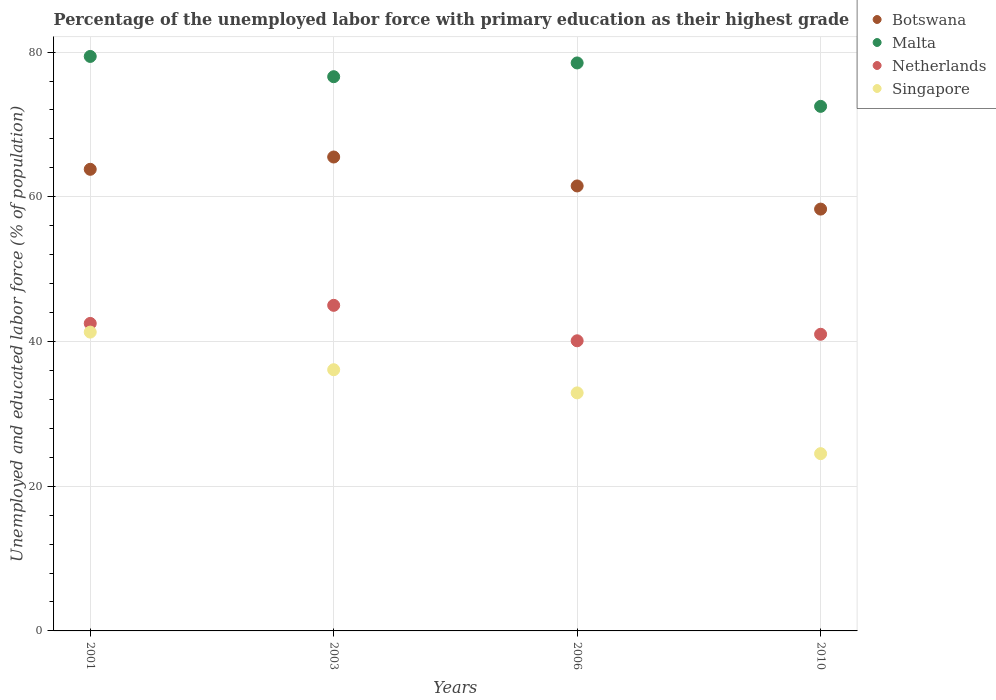How many different coloured dotlines are there?
Offer a very short reply. 4. What is the percentage of the unemployed labor force with primary education in Malta in 2010?
Make the answer very short. 72.5. Across all years, what is the maximum percentage of the unemployed labor force with primary education in Malta?
Your answer should be very brief. 79.4. Across all years, what is the minimum percentage of the unemployed labor force with primary education in Netherlands?
Ensure brevity in your answer.  40.1. In which year was the percentage of the unemployed labor force with primary education in Netherlands maximum?
Offer a terse response. 2003. In which year was the percentage of the unemployed labor force with primary education in Netherlands minimum?
Offer a terse response. 2006. What is the total percentage of the unemployed labor force with primary education in Singapore in the graph?
Your answer should be very brief. 134.8. What is the difference between the percentage of the unemployed labor force with primary education in Netherlands in 2001 and that in 2010?
Your answer should be compact. 1.5. What is the average percentage of the unemployed labor force with primary education in Netherlands per year?
Offer a very short reply. 42.15. In the year 2006, what is the difference between the percentage of the unemployed labor force with primary education in Netherlands and percentage of the unemployed labor force with primary education in Singapore?
Make the answer very short. 7.2. In how many years, is the percentage of the unemployed labor force with primary education in Singapore greater than 28 %?
Provide a succinct answer. 3. What is the ratio of the percentage of the unemployed labor force with primary education in Botswana in 2003 to that in 2010?
Your answer should be very brief. 1.12. Is the percentage of the unemployed labor force with primary education in Singapore in 2003 less than that in 2006?
Offer a terse response. No. What is the difference between the highest and the second highest percentage of the unemployed labor force with primary education in Botswana?
Give a very brief answer. 1.7. What is the difference between the highest and the lowest percentage of the unemployed labor force with primary education in Singapore?
Ensure brevity in your answer.  16.8. Is the sum of the percentage of the unemployed labor force with primary education in Botswana in 2001 and 2003 greater than the maximum percentage of the unemployed labor force with primary education in Netherlands across all years?
Offer a very short reply. Yes. Is it the case that in every year, the sum of the percentage of the unemployed labor force with primary education in Malta and percentage of the unemployed labor force with primary education in Netherlands  is greater than the sum of percentage of the unemployed labor force with primary education in Singapore and percentage of the unemployed labor force with primary education in Botswana?
Ensure brevity in your answer.  Yes. How many dotlines are there?
Ensure brevity in your answer.  4. What is the difference between two consecutive major ticks on the Y-axis?
Provide a succinct answer. 20. Does the graph contain grids?
Your answer should be compact. Yes. Where does the legend appear in the graph?
Your response must be concise. Top right. How many legend labels are there?
Provide a succinct answer. 4. How are the legend labels stacked?
Provide a short and direct response. Vertical. What is the title of the graph?
Your response must be concise. Percentage of the unemployed labor force with primary education as their highest grade. Does "Mexico" appear as one of the legend labels in the graph?
Your answer should be very brief. No. What is the label or title of the Y-axis?
Offer a very short reply. Unemployed and educated labor force (% of population). What is the Unemployed and educated labor force (% of population) in Botswana in 2001?
Ensure brevity in your answer.  63.8. What is the Unemployed and educated labor force (% of population) in Malta in 2001?
Provide a succinct answer. 79.4. What is the Unemployed and educated labor force (% of population) in Netherlands in 2001?
Keep it short and to the point. 42.5. What is the Unemployed and educated labor force (% of population) of Singapore in 2001?
Your answer should be compact. 41.3. What is the Unemployed and educated labor force (% of population) of Botswana in 2003?
Your response must be concise. 65.5. What is the Unemployed and educated labor force (% of population) in Malta in 2003?
Offer a terse response. 76.6. What is the Unemployed and educated labor force (% of population) of Singapore in 2003?
Your answer should be compact. 36.1. What is the Unemployed and educated labor force (% of population) in Botswana in 2006?
Give a very brief answer. 61.5. What is the Unemployed and educated labor force (% of population) in Malta in 2006?
Provide a short and direct response. 78.5. What is the Unemployed and educated labor force (% of population) of Netherlands in 2006?
Offer a very short reply. 40.1. What is the Unemployed and educated labor force (% of population) of Singapore in 2006?
Keep it short and to the point. 32.9. What is the Unemployed and educated labor force (% of population) in Botswana in 2010?
Offer a terse response. 58.3. What is the Unemployed and educated labor force (% of population) in Malta in 2010?
Your answer should be very brief. 72.5. What is the Unemployed and educated labor force (% of population) in Singapore in 2010?
Your response must be concise. 24.5. Across all years, what is the maximum Unemployed and educated labor force (% of population) in Botswana?
Give a very brief answer. 65.5. Across all years, what is the maximum Unemployed and educated labor force (% of population) of Malta?
Your answer should be compact. 79.4. Across all years, what is the maximum Unemployed and educated labor force (% of population) of Netherlands?
Your answer should be compact. 45. Across all years, what is the maximum Unemployed and educated labor force (% of population) in Singapore?
Give a very brief answer. 41.3. Across all years, what is the minimum Unemployed and educated labor force (% of population) of Botswana?
Your response must be concise. 58.3. Across all years, what is the minimum Unemployed and educated labor force (% of population) of Malta?
Offer a terse response. 72.5. Across all years, what is the minimum Unemployed and educated labor force (% of population) of Netherlands?
Provide a succinct answer. 40.1. What is the total Unemployed and educated labor force (% of population) in Botswana in the graph?
Make the answer very short. 249.1. What is the total Unemployed and educated labor force (% of population) in Malta in the graph?
Provide a succinct answer. 307. What is the total Unemployed and educated labor force (% of population) of Netherlands in the graph?
Give a very brief answer. 168.6. What is the total Unemployed and educated labor force (% of population) of Singapore in the graph?
Give a very brief answer. 134.8. What is the difference between the Unemployed and educated labor force (% of population) of Singapore in 2001 and that in 2003?
Your answer should be very brief. 5.2. What is the difference between the Unemployed and educated labor force (% of population) in Singapore in 2001 and that in 2006?
Offer a terse response. 8.4. What is the difference between the Unemployed and educated labor force (% of population) of Malta in 2001 and that in 2010?
Provide a short and direct response. 6.9. What is the difference between the Unemployed and educated labor force (% of population) of Netherlands in 2001 and that in 2010?
Make the answer very short. 1.5. What is the difference between the Unemployed and educated labor force (% of population) in Malta in 2003 and that in 2006?
Give a very brief answer. -1.9. What is the difference between the Unemployed and educated labor force (% of population) of Netherlands in 2003 and that in 2006?
Offer a very short reply. 4.9. What is the difference between the Unemployed and educated labor force (% of population) in Malta in 2003 and that in 2010?
Provide a succinct answer. 4.1. What is the difference between the Unemployed and educated labor force (% of population) of Netherlands in 2003 and that in 2010?
Give a very brief answer. 4. What is the difference between the Unemployed and educated labor force (% of population) of Malta in 2006 and that in 2010?
Your answer should be very brief. 6. What is the difference between the Unemployed and educated labor force (% of population) in Netherlands in 2006 and that in 2010?
Offer a very short reply. -0.9. What is the difference between the Unemployed and educated labor force (% of population) of Singapore in 2006 and that in 2010?
Your response must be concise. 8.4. What is the difference between the Unemployed and educated labor force (% of population) of Botswana in 2001 and the Unemployed and educated labor force (% of population) of Malta in 2003?
Your response must be concise. -12.8. What is the difference between the Unemployed and educated labor force (% of population) in Botswana in 2001 and the Unemployed and educated labor force (% of population) in Netherlands in 2003?
Keep it short and to the point. 18.8. What is the difference between the Unemployed and educated labor force (% of population) of Botswana in 2001 and the Unemployed and educated labor force (% of population) of Singapore in 2003?
Provide a succinct answer. 27.7. What is the difference between the Unemployed and educated labor force (% of population) of Malta in 2001 and the Unemployed and educated labor force (% of population) of Netherlands in 2003?
Your answer should be compact. 34.4. What is the difference between the Unemployed and educated labor force (% of population) of Malta in 2001 and the Unemployed and educated labor force (% of population) of Singapore in 2003?
Your response must be concise. 43.3. What is the difference between the Unemployed and educated labor force (% of population) of Botswana in 2001 and the Unemployed and educated labor force (% of population) of Malta in 2006?
Ensure brevity in your answer.  -14.7. What is the difference between the Unemployed and educated labor force (% of population) in Botswana in 2001 and the Unemployed and educated labor force (% of population) in Netherlands in 2006?
Your answer should be compact. 23.7. What is the difference between the Unemployed and educated labor force (% of population) in Botswana in 2001 and the Unemployed and educated labor force (% of population) in Singapore in 2006?
Provide a succinct answer. 30.9. What is the difference between the Unemployed and educated labor force (% of population) of Malta in 2001 and the Unemployed and educated labor force (% of population) of Netherlands in 2006?
Offer a terse response. 39.3. What is the difference between the Unemployed and educated labor force (% of population) in Malta in 2001 and the Unemployed and educated labor force (% of population) in Singapore in 2006?
Offer a very short reply. 46.5. What is the difference between the Unemployed and educated labor force (% of population) of Botswana in 2001 and the Unemployed and educated labor force (% of population) of Malta in 2010?
Keep it short and to the point. -8.7. What is the difference between the Unemployed and educated labor force (% of population) of Botswana in 2001 and the Unemployed and educated labor force (% of population) of Netherlands in 2010?
Provide a short and direct response. 22.8. What is the difference between the Unemployed and educated labor force (% of population) of Botswana in 2001 and the Unemployed and educated labor force (% of population) of Singapore in 2010?
Make the answer very short. 39.3. What is the difference between the Unemployed and educated labor force (% of population) in Malta in 2001 and the Unemployed and educated labor force (% of population) in Netherlands in 2010?
Provide a short and direct response. 38.4. What is the difference between the Unemployed and educated labor force (% of population) in Malta in 2001 and the Unemployed and educated labor force (% of population) in Singapore in 2010?
Give a very brief answer. 54.9. What is the difference between the Unemployed and educated labor force (% of population) of Botswana in 2003 and the Unemployed and educated labor force (% of population) of Netherlands in 2006?
Ensure brevity in your answer.  25.4. What is the difference between the Unemployed and educated labor force (% of population) in Botswana in 2003 and the Unemployed and educated labor force (% of population) in Singapore in 2006?
Your answer should be compact. 32.6. What is the difference between the Unemployed and educated labor force (% of population) in Malta in 2003 and the Unemployed and educated labor force (% of population) in Netherlands in 2006?
Your answer should be compact. 36.5. What is the difference between the Unemployed and educated labor force (% of population) of Malta in 2003 and the Unemployed and educated labor force (% of population) of Singapore in 2006?
Provide a short and direct response. 43.7. What is the difference between the Unemployed and educated labor force (% of population) in Malta in 2003 and the Unemployed and educated labor force (% of population) in Netherlands in 2010?
Your answer should be compact. 35.6. What is the difference between the Unemployed and educated labor force (% of population) in Malta in 2003 and the Unemployed and educated labor force (% of population) in Singapore in 2010?
Provide a short and direct response. 52.1. What is the difference between the Unemployed and educated labor force (% of population) of Botswana in 2006 and the Unemployed and educated labor force (% of population) of Malta in 2010?
Give a very brief answer. -11. What is the difference between the Unemployed and educated labor force (% of population) of Botswana in 2006 and the Unemployed and educated labor force (% of population) of Netherlands in 2010?
Keep it short and to the point. 20.5. What is the difference between the Unemployed and educated labor force (% of population) in Botswana in 2006 and the Unemployed and educated labor force (% of population) in Singapore in 2010?
Your answer should be compact. 37. What is the difference between the Unemployed and educated labor force (% of population) in Malta in 2006 and the Unemployed and educated labor force (% of population) in Netherlands in 2010?
Offer a very short reply. 37.5. What is the difference between the Unemployed and educated labor force (% of population) in Malta in 2006 and the Unemployed and educated labor force (% of population) in Singapore in 2010?
Offer a terse response. 54. What is the average Unemployed and educated labor force (% of population) of Botswana per year?
Offer a very short reply. 62.27. What is the average Unemployed and educated labor force (% of population) of Malta per year?
Your answer should be compact. 76.75. What is the average Unemployed and educated labor force (% of population) of Netherlands per year?
Offer a very short reply. 42.15. What is the average Unemployed and educated labor force (% of population) in Singapore per year?
Your answer should be very brief. 33.7. In the year 2001, what is the difference between the Unemployed and educated labor force (% of population) in Botswana and Unemployed and educated labor force (% of population) in Malta?
Your answer should be compact. -15.6. In the year 2001, what is the difference between the Unemployed and educated labor force (% of population) in Botswana and Unemployed and educated labor force (% of population) in Netherlands?
Keep it short and to the point. 21.3. In the year 2001, what is the difference between the Unemployed and educated labor force (% of population) of Botswana and Unemployed and educated labor force (% of population) of Singapore?
Keep it short and to the point. 22.5. In the year 2001, what is the difference between the Unemployed and educated labor force (% of population) in Malta and Unemployed and educated labor force (% of population) in Netherlands?
Your response must be concise. 36.9. In the year 2001, what is the difference between the Unemployed and educated labor force (% of population) in Malta and Unemployed and educated labor force (% of population) in Singapore?
Your response must be concise. 38.1. In the year 2001, what is the difference between the Unemployed and educated labor force (% of population) of Netherlands and Unemployed and educated labor force (% of population) of Singapore?
Your answer should be compact. 1.2. In the year 2003, what is the difference between the Unemployed and educated labor force (% of population) of Botswana and Unemployed and educated labor force (% of population) of Malta?
Your response must be concise. -11.1. In the year 2003, what is the difference between the Unemployed and educated labor force (% of population) of Botswana and Unemployed and educated labor force (% of population) of Singapore?
Offer a terse response. 29.4. In the year 2003, what is the difference between the Unemployed and educated labor force (% of population) in Malta and Unemployed and educated labor force (% of population) in Netherlands?
Your answer should be very brief. 31.6. In the year 2003, what is the difference between the Unemployed and educated labor force (% of population) of Malta and Unemployed and educated labor force (% of population) of Singapore?
Offer a very short reply. 40.5. In the year 2003, what is the difference between the Unemployed and educated labor force (% of population) of Netherlands and Unemployed and educated labor force (% of population) of Singapore?
Provide a succinct answer. 8.9. In the year 2006, what is the difference between the Unemployed and educated labor force (% of population) in Botswana and Unemployed and educated labor force (% of population) in Netherlands?
Make the answer very short. 21.4. In the year 2006, what is the difference between the Unemployed and educated labor force (% of population) of Botswana and Unemployed and educated labor force (% of population) of Singapore?
Keep it short and to the point. 28.6. In the year 2006, what is the difference between the Unemployed and educated labor force (% of population) of Malta and Unemployed and educated labor force (% of population) of Netherlands?
Your answer should be very brief. 38.4. In the year 2006, what is the difference between the Unemployed and educated labor force (% of population) in Malta and Unemployed and educated labor force (% of population) in Singapore?
Keep it short and to the point. 45.6. In the year 2010, what is the difference between the Unemployed and educated labor force (% of population) of Botswana and Unemployed and educated labor force (% of population) of Netherlands?
Provide a short and direct response. 17.3. In the year 2010, what is the difference between the Unemployed and educated labor force (% of population) in Botswana and Unemployed and educated labor force (% of population) in Singapore?
Provide a succinct answer. 33.8. In the year 2010, what is the difference between the Unemployed and educated labor force (% of population) of Malta and Unemployed and educated labor force (% of population) of Netherlands?
Keep it short and to the point. 31.5. In the year 2010, what is the difference between the Unemployed and educated labor force (% of population) of Malta and Unemployed and educated labor force (% of population) of Singapore?
Make the answer very short. 48. What is the ratio of the Unemployed and educated labor force (% of population) of Botswana in 2001 to that in 2003?
Ensure brevity in your answer.  0.97. What is the ratio of the Unemployed and educated labor force (% of population) in Malta in 2001 to that in 2003?
Ensure brevity in your answer.  1.04. What is the ratio of the Unemployed and educated labor force (% of population) in Netherlands in 2001 to that in 2003?
Provide a short and direct response. 0.94. What is the ratio of the Unemployed and educated labor force (% of population) in Singapore in 2001 to that in 2003?
Make the answer very short. 1.14. What is the ratio of the Unemployed and educated labor force (% of population) in Botswana in 2001 to that in 2006?
Give a very brief answer. 1.04. What is the ratio of the Unemployed and educated labor force (% of population) in Malta in 2001 to that in 2006?
Keep it short and to the point. 1.01. What is the ratio of the Unemployed and educated labor force (% of population) of Netherlands in 2001 to that in 2006?
Provide a short and direct response. 1.06. What is the ratio of the Unemployed and educated labor force (% of population) in Singapore in 2001 to that in 2006?
Provide a succinct answer. 1.26. What is the ratio of the Unemployed and educated labor force (% of population) of Botswana in 2001 to that in 2010?
Provide a succinct answer. 1.09. What is the ratio of the Unemployed and educated labor force (% of population) of Malta in 2001 to that in 2010?
Ensure brevity in your answer.  1.1. What is the ratio of the Unemployed and educated labor force (% of population) in Netherlands in 2001 to that in 2010?
Your response must be concise. 1.04. What is the ratio of the Unemployed and educated labor force (% of population) of Singapore in 2001 to that in 2010?
Your response must be concise. 1.69. What is the ratio of the Unemployed and educated labor force (% of population) in Botswana in 2003 to that in 2006?
Make the answer very short. 1.06. What is the ratio of the Unemployed and educated labor force (% of population) of Malta in 2003 to that in 2006?
Your answer should be very brief. 0.98. What is the ratio of the Unemployed and educated labor force (% of population) of Netherlands in 2003 to that in 2006?
Provide a succinct answer. 1.12. What is the ratio of the Unemployed and educated labor force (% of population) of Singapore in 2003 to that in 2006?
Your answer should be compact. 1.1. What is the ratio of the Unemployed and educated labor force (% of population) of Botswana in 2003 to that in 2010?
Make the answer very short. 1.12. What is the ratio of the Unemployed and educated labor force (% of population) in Malta in 2003 to that in 2010?
Provide a succinct answer. 1.06. What is the ratio of the Unemployed and educated labor force (% of population) of Netherlands in 2003 to that in 2010?
Give a very brief answer. 1.1. What is the ratio of the Unemployed and educated labor force (% of population) in Singapore in 2003 to that in 2010?
Offer a terse response. 1.47. What is the ratio of the Unemployed and educated labor force (% of population) of Botswana in 2006 to that in 2010?
Your answer should be compact. 1.05. What is the ratio of the Unemployed and educated labor force (% of population) in Malta in 2006 to that in 2010?
Offer a terse response. 1.08. What is the ratio of the Unemployed and educated labor force (% of population) of Netherlands in 2006 to that in 2010?
Give a very brief answer. 0.98. What is the ratio of the Unemployed and educated labor force (% of population) in Singapore in 2006 to that in 2010?
Your answer should be compact. 1.34. What is the difference between the highest and the second highest Unemployed and educated labor force (% of population) of Botswana?
Provide a short and direct response. 1.7. What is the difference between the highest and the second highest Unemployed and educated labor force (% of population) of Netherlands?
Your answer should be compact. 2.5. What is the difference between the highest and the lowest Unemployed and educated labor force (% of population) in Netherlands?
Make the answer very short. 4.9. 